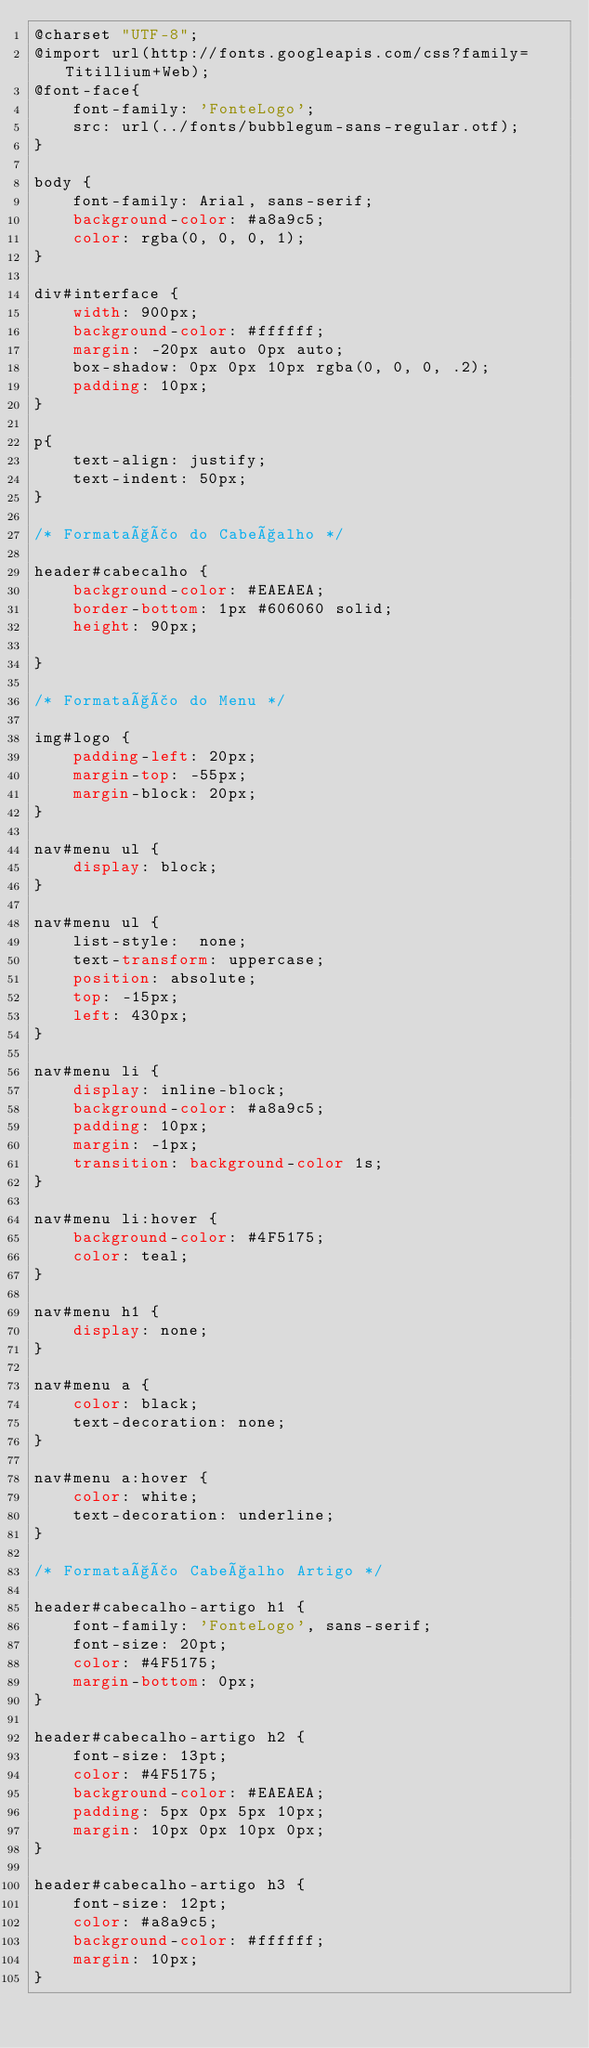<code> <loc_0><loc_0><loc_500><loc_500><_CSS_>@charset "UTF-8";
@import url(http://fonts.googleapis.com/css?family=Titillium+Web);
@font-face{
    font-family: 'FonteLogo';
    src: url(../fonts/bubblegum-sans-regular.otf);
}

body {
    font-family: Arial, sans-serif;
    background-color: #a8a9c5;
    color: rgba(0, 0, 0, 1);
}

div#interface {
    width: 900px;
    background-color: #ffffff;
    margin: -20px auto 0px auto;
    box-shadow: 0px 0px 10px rgba(0, 0, 0, .2);
    padding: 10px;
}

p{
    text-align: justify;
    text-indent: 50px;
}

/* Formatação do Cabeçalho */

header#cabecalho {
    background-color: #EAEAEA;
    border-bottom: 1px #606060 solid;
    height: 90px;

}

/* Formatação do Menu */

img#logo {
    padding-left: 20px;
    margin-top: -55px;
    margin-block: 20px;
}

nav#menu ul {
    display: block;
}

nav#menu ul {
    list-style:  none;
    text-transform: uppercase;
    position: absolute;
    top: -15px;
    left: 430px;
}

nav#menu li {
    display: inline-block;
    background-color: #a8a9c5;
    padding: 10px;
    margin: -1px;
    transition: background-color 1s;
}

nav#menu li:hover {
    background-color: #4F5175;
    color: teal;
}

nav#menu h1 {
    display: none;
}

nav#menu a {
    color: black;
    text-decoration: none;
}

nav#menu a:hover {
    color: white;
    text-decoration: underline;
}

/* Formatação Cabeçalho Artigo */

header#cabecalho-artigo h1 {
    font-family: 'FonteLogo', sans-serif;
    font-size: 20pt;
    color: #4F5175;
    margin-bottom: 0px;
}

header#cabecalho-artigo h2 {
    font-size: 13pt;
    color: #4F5175;
    background-color: #EAEAEA;
    padding: 5px 0px 5px 10px;
    margin: 10px 0px 10px 0px;
}

header#cabecalho-artigo h3 {
    font-size: 12pt;
    color: #a8a9c5;
    background-color: #ffffff;
    margin: 10px;
}
</code> 